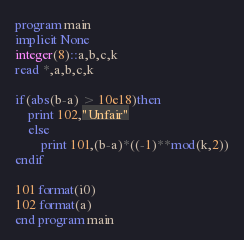Convert code to text. <code><loc_0><loc_0><loc_500><loc_500><_FORTRAN_>program main
implicit None
integer(8)::a,b,c,k
read *,a,b,c,k

if(abs(b-a) > 10e18)then 
	print 102,"Unfair"
	else
		print 101,(b-a)*((-1)**mod(k,2))
endif

101 format(i0)
102 format(a)
end program main</code> 